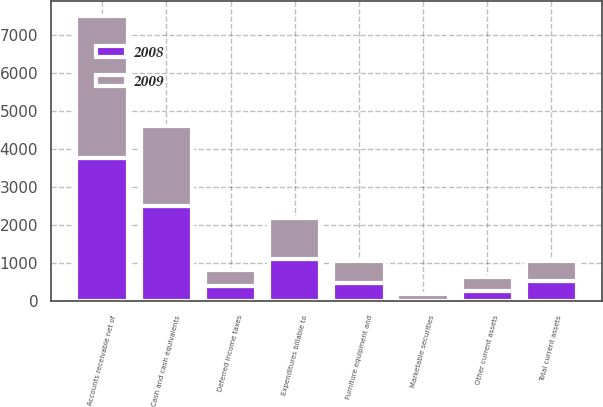Convert chart to OTSL. <chart><loc_0><loc_0><loc_500><loc_500><stacked_bar_chart><ecel><fcel>Cash and cash equivalents<fcel>Marketable securities<fcel>Accounts receivable net of<fcel>Expenditures billable to<fcel>Other current assets<fcel>Total current assets<fcel>Furniture equipment and<fcel>Deferred income taxes<nl><fcel>2008<fcel>2495.2<fcel>10.9<fcel>3756.5<fcel>1100.1<fcel>275<fcel>525.8<fcel>490.1<fcel>398.3<nl><fcel>2009<fcel>2107.2<fcel>167.7<fcel>3746.5<fcel>1099.5<fcel>366.7<fcel>525.8<fcel>561.5<fcel>416.8<nl></chart> 